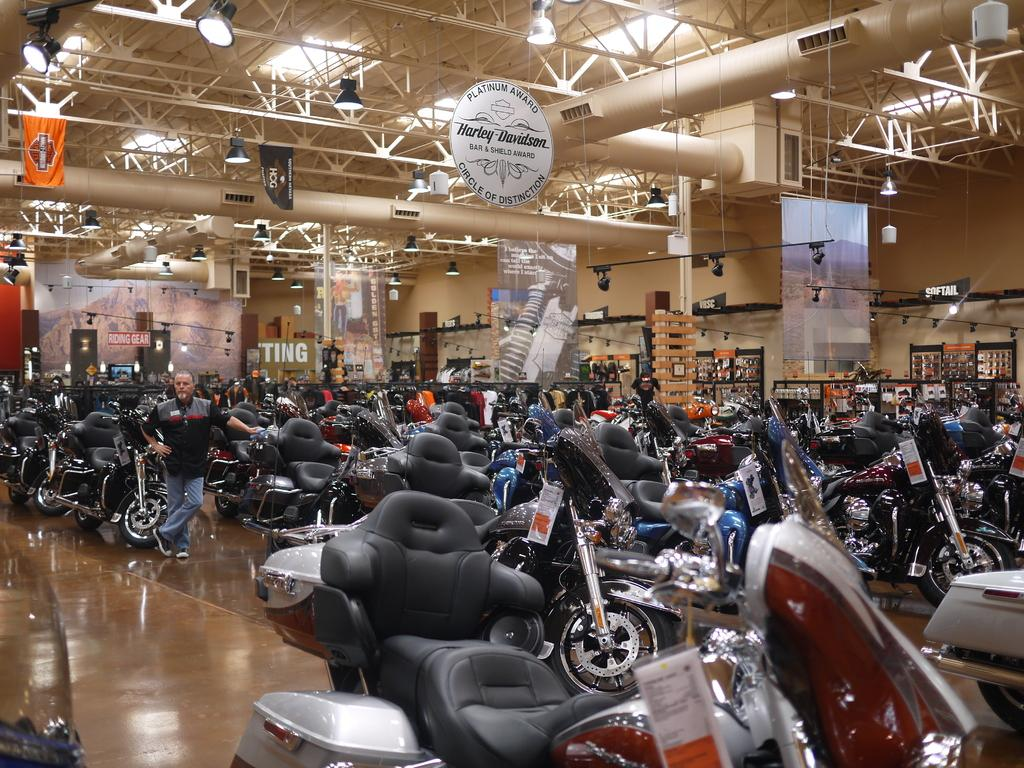What types of objects can be seen in the image? There are vehicles and people standing on the ground in the image. What can be seen in the background of the image? There are banners, lights on the ceiling, boards, and other objects visible in the background of the image. What type of twig can be seen in the image? There is no twig present in the image. How much sugar is visible in the image? There is no sugar present in the image. 